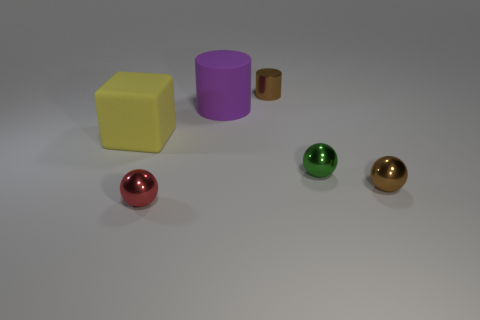Add 2 small spheres. How many objects exist? 8 Subtract all cubes. How many objects are left? 5 Add 1 metal cylinders. How many metal cylinders are left? 2 Add 4 red metal things. How many red metal things exist? 5 Subtract 0 yellow balls. How many objects are left? 6 Subtract all tiny cylinders. Subtract all green objects. How many objects are left? 4 